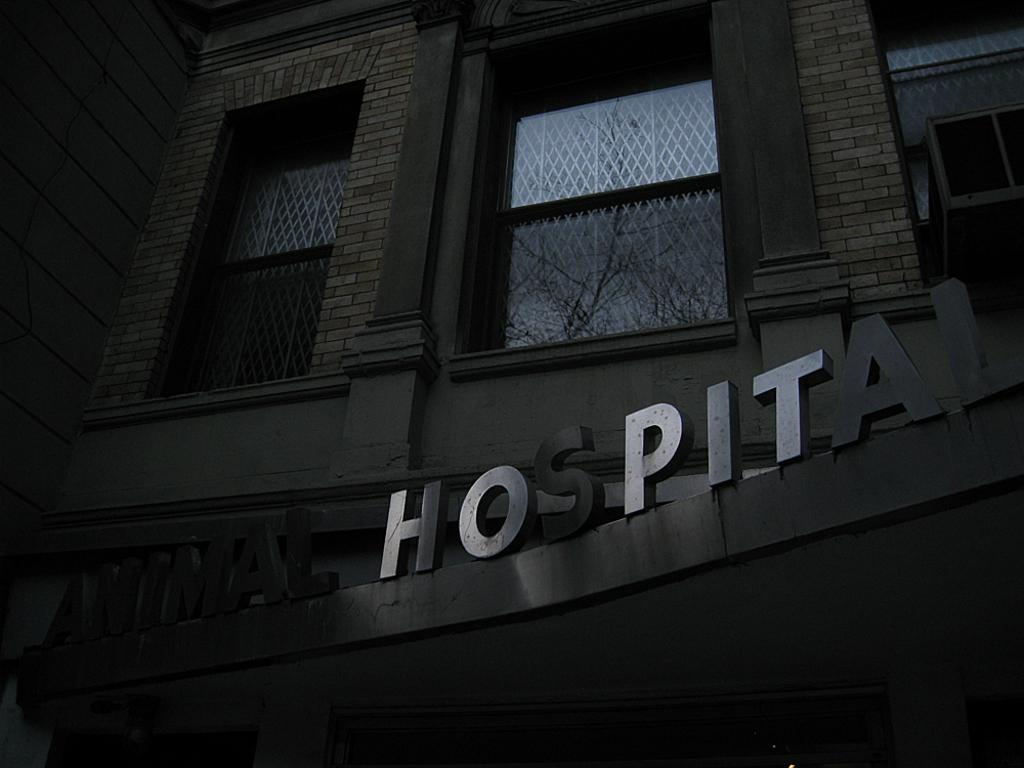What type of establishment is shown in the image? The image depicts an animal hospital. What feature of the building can be seen from the outside? The animal hospital has windows. What device is present to regulate the temperature inside the animal hospital? The animal hospital has an air conditioner. What type of wall can be seen in the image? There is no specific wall mentioned or visible in the image; it depicts an animal hospital as a whole. What request is being made by the animals in the image? There are no animals shown making any requests in the image. Is there a bomb visible in the image? No, there is no bomb present in the image. 